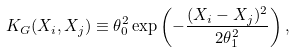Convert formula to latex. <formula><loc_0><loc_0><loc_500><loc_500>K _ { G } ( X _ { i } , X _ { j } ) \equiv \theta _ { 0 } ^ { 2 } \exp \left ( - \frac { ( X _ { i } - X _ { j } ) ^ { 2 } } { 2 \theta _ { 1 } ^ { 2 } } \right ) ,</formula> 